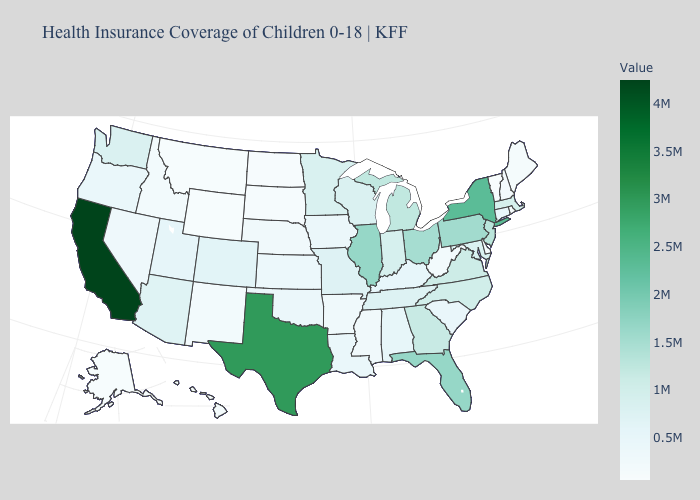Among the states that border Georgia , which have the lowest value?
Quick response, please. South Carolina. Which states have the highest value in the USA?
Short answer required. California. Does Vermont have the lowest value in the USA?
Answer briefly. Yes. Does California have the highest value in the USA?
Give a very brief answer. Yes. Which states hav the highest value in the MidWest?
Be succinct. Illinois. 